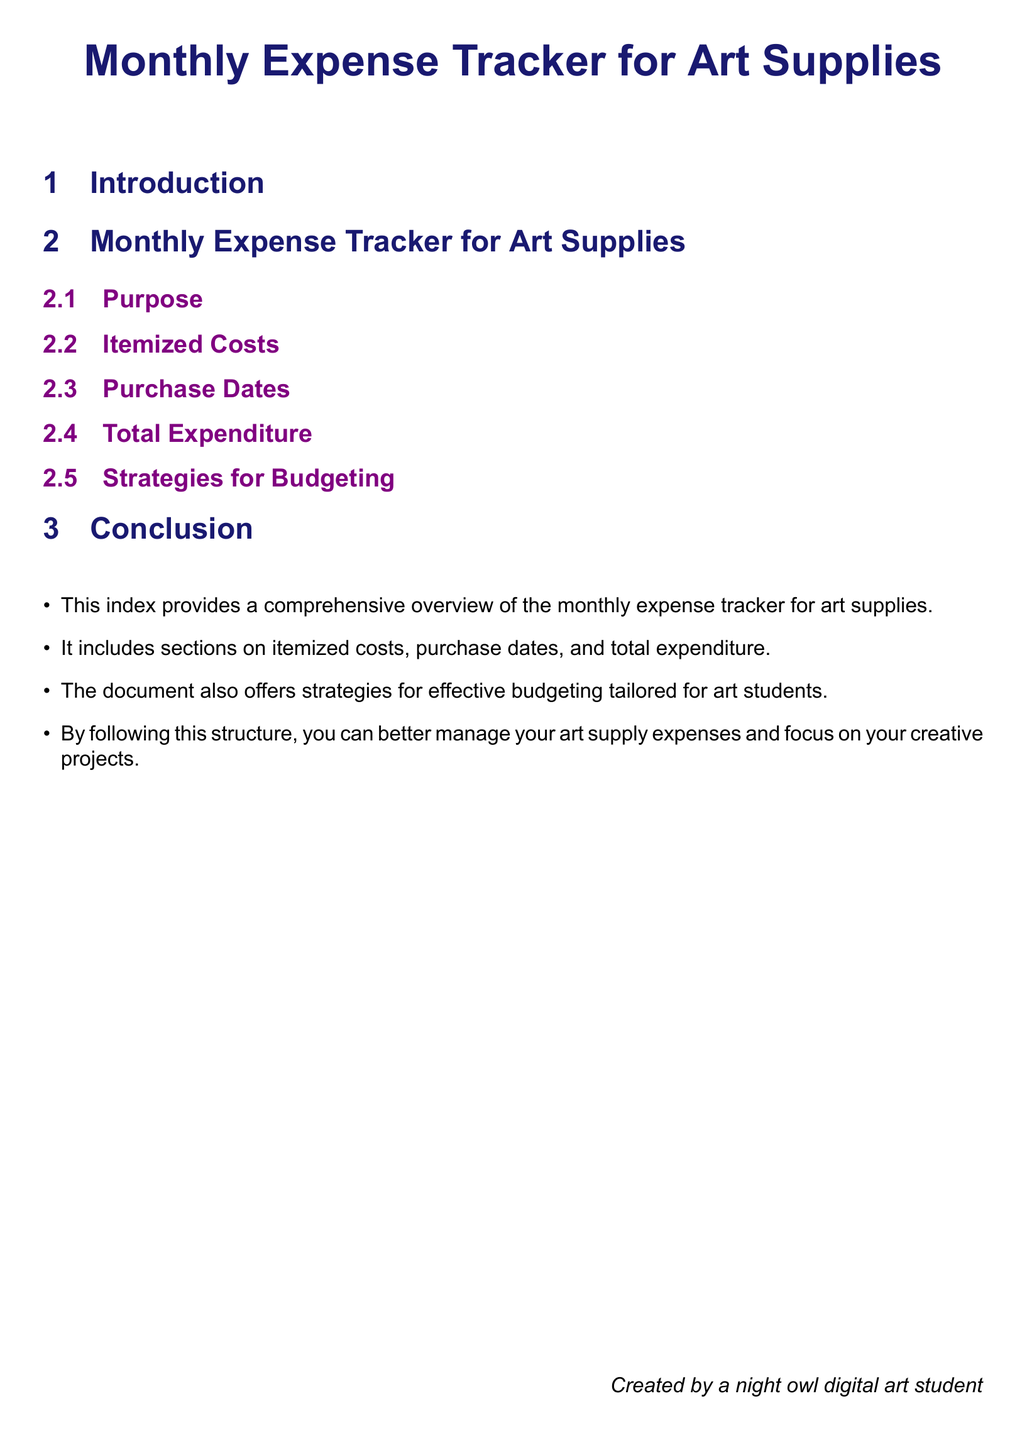what is the title of the document? The title appears at the beginning of the document and summarizes its purpose.
Answer: Monthly Expense Tracker for Art Supplies what color is used for section titles? The document specifies the color used for section titles in the formatting section.
Answer: nightblue what is included in the index? The index summarizes the sections that are part of the document structure.
Answer: Itemized costs, purchase dates, total expenditure, strategies for budgeting how many sections are in the document? The document outlines the sections, and counting these gives the number of sections present.
Answer: 5 what is the purpose of the document? The purpose is outlined in a specific subsection of the document.
Answer: Track monthly expenses for art supplies who created the document? The creator is mentioned at the bottom of the document.
Answer: A night owl digital art student what color is used for subsection titles? The color for subsections is specified in the title formatting part.
Answer: creativepurple what is the last section of the document? The final section listed in the document's structure.
Answer: Conclusion 